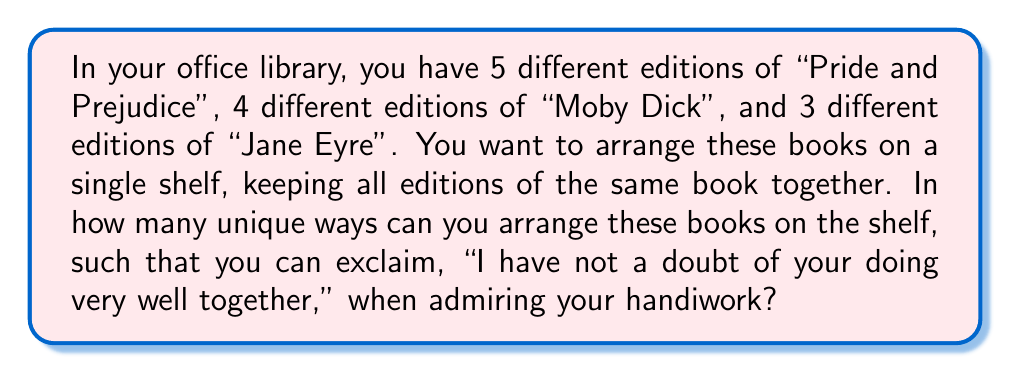Help me with this question. Let's approach this step-by-step:

1) First, we need to consider the arrangement of the three different books. This is a straightforward permutation of 3 items, which gives us $3!$ ways.

2) Now, for each of these 3! arrangements of the books, we need to consider the arrangements of the editions within each book:
   - "Pride and Prejudice" has 5 editions: $5!$ ways
   - "Moby Dick" has 4 editions: $4!$ ways
   - "Jane Eyre" has 3 editions: $3!$ ways

3) By the Multiplication Principle, for each arrangement of the books, we multiply the number of ways to arrange the editions:

   $5! \cdot 4! \cdot 3!$

4) Finally, we multiply this by the number of ways to arrange the books themselves:

   $3! \cdot 5! \cdot 4! \cdot 3!$

5) Let's calculate this:
   $3! \cdot 5! \cdot 4! \cdot 3! = 6 \cdot 120 \cdot 24 \cdot 6 = 103,680$

Therefore, there are 103,680 unique ways to arrange the books on the shelf.
Answer: 103,680 